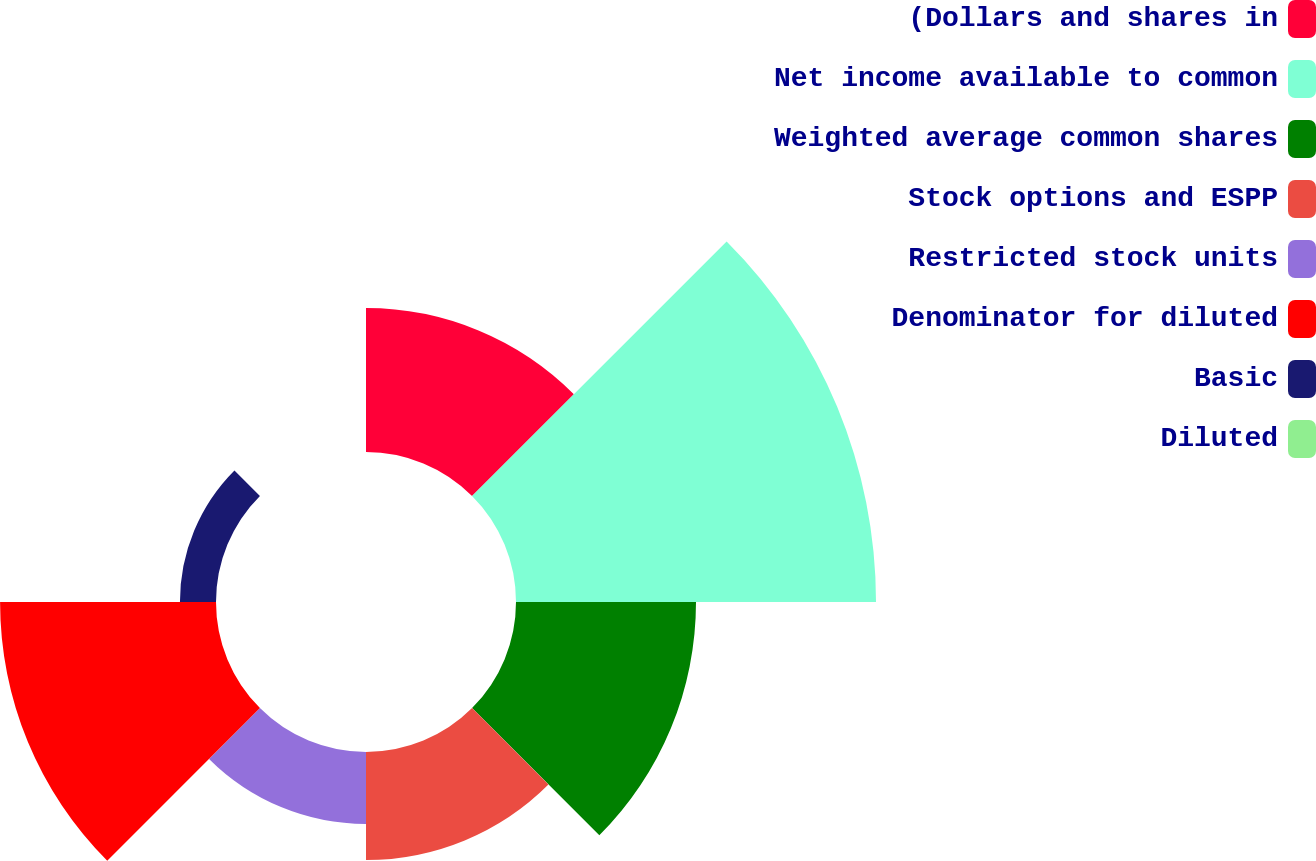<chart> <loc_0><loc_0><loc_500><loc_500><pie_chart><fcel>(Dollars and shares in<fcel>Net income available to common<fcel>Weighted average common shares<fcel>Stock options and ESPP<fcel>Restricted stock units<fcel>Denominator for diluted<fcel>Basic<fcel>Diluted<nl><fcel>12.9%<fcel>32.26%<fcel>16.13%<fcel>9.68%<fcel>6.45%<fcel>19.35%<fcel>3.23%<fcel>0.0%<nl></chart> 